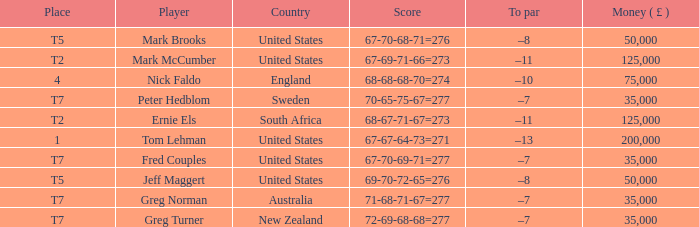What is To par, when Country is "United States", when Money ( £ ) is greater than 125,000, and when Score is "67-70-68-71=276"? None. 